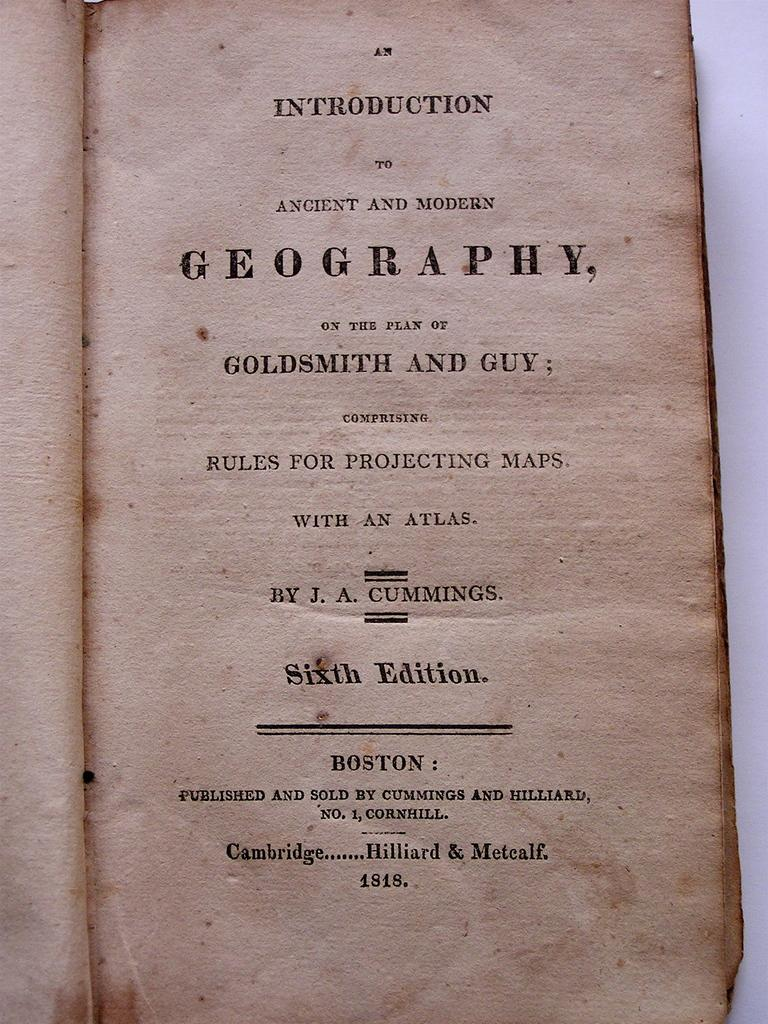<image>
Share a concise interpretation of the image provided. The cover page of An Introduction to Ancient and Modern Geography, comprising rules for projecting maps, published in 1818. 